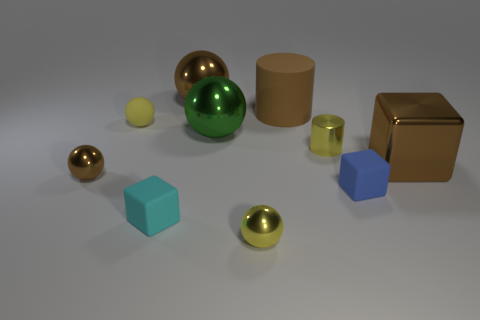Subtract all small brown balls. How many balls are left? 4 Subtract all purple balls. Subtract all green cylinders. How many balls are left? 5 Subtract all cylinders. How many objects are left? 8 Subtract 2 brown spheres. How many objects are left? 8 Subtract all brown cylinders. Subtract all yellow spheres. How many objects are left? 7 Add 3 tiny cyan cubes. How many tiny cyan cubes are left? 4 Add 4 large balls. How many large balls exist? 6 